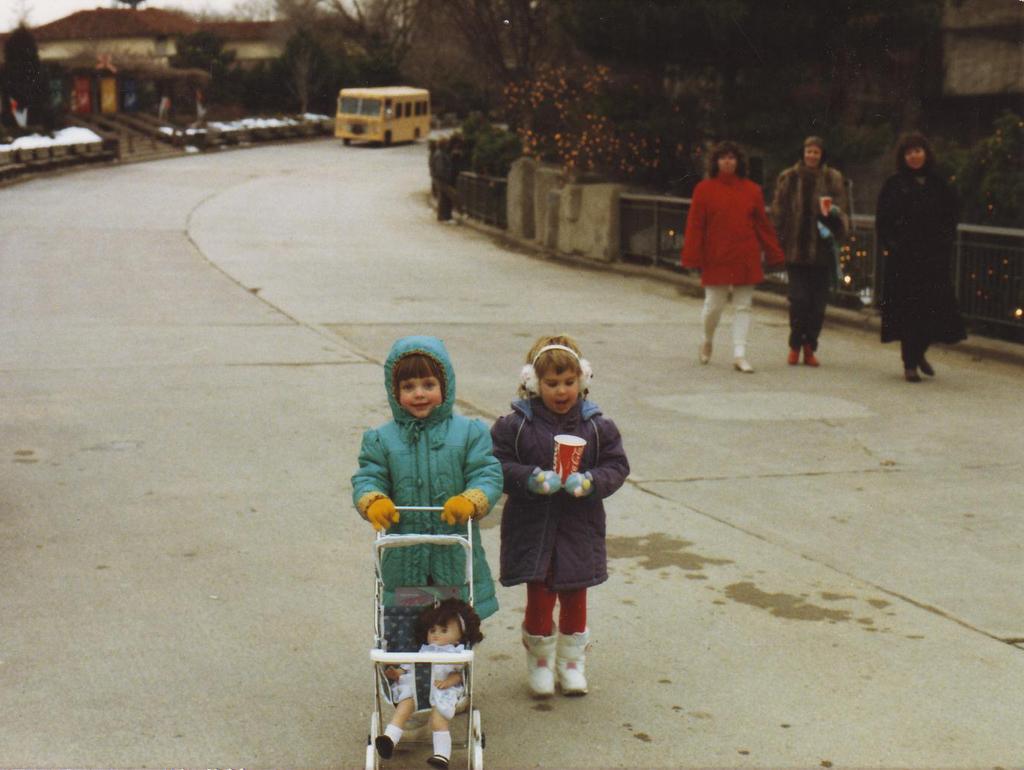Could you give a brief overview of what you see in this image? In this picture we can see a bus and three women are walking and two girls are standing on the road, stroller with a toy on it, trees, fence and in the background we can see houses. 